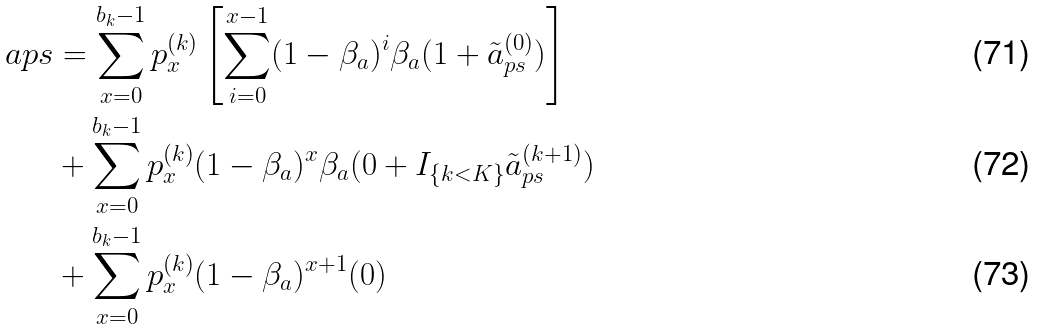Convert formula to latex. <formula><loc_0><loc_0><loc_500><loc_500>\ a p s & = \sum _ { x = 0 } ^ { b _ { k } - 1 } p _ { x } ^ { ( k ) } \left [ \sum _ { i = 0 } ^ { x - 1 } ( 1 - \beta _ { a } ) ^ { i } \beta _ { a } ( 1 + \tilde { a } _ { p s } ^ { ( 0 ) } ) \right ] \\ & + \sum _ { x = 0 } ^ { b _ { k } - 1 } p _ { x } ^ { ( k ) } ( 1 - \beta _ { a } ) ^ { x } \beta _ { a } ( 0 + I _ { \{ k < K \} } \tilde { a } _ { p s } ^ { ( k + 1 ) } ) \\ & + \sum _ { x = 0 } ^ { b _ { k } - 1 } p _ { x } ^ { ( k ) } ( 1 - \beta _ { a } ) ^ { x + 1 } ( 0 )</formula> 